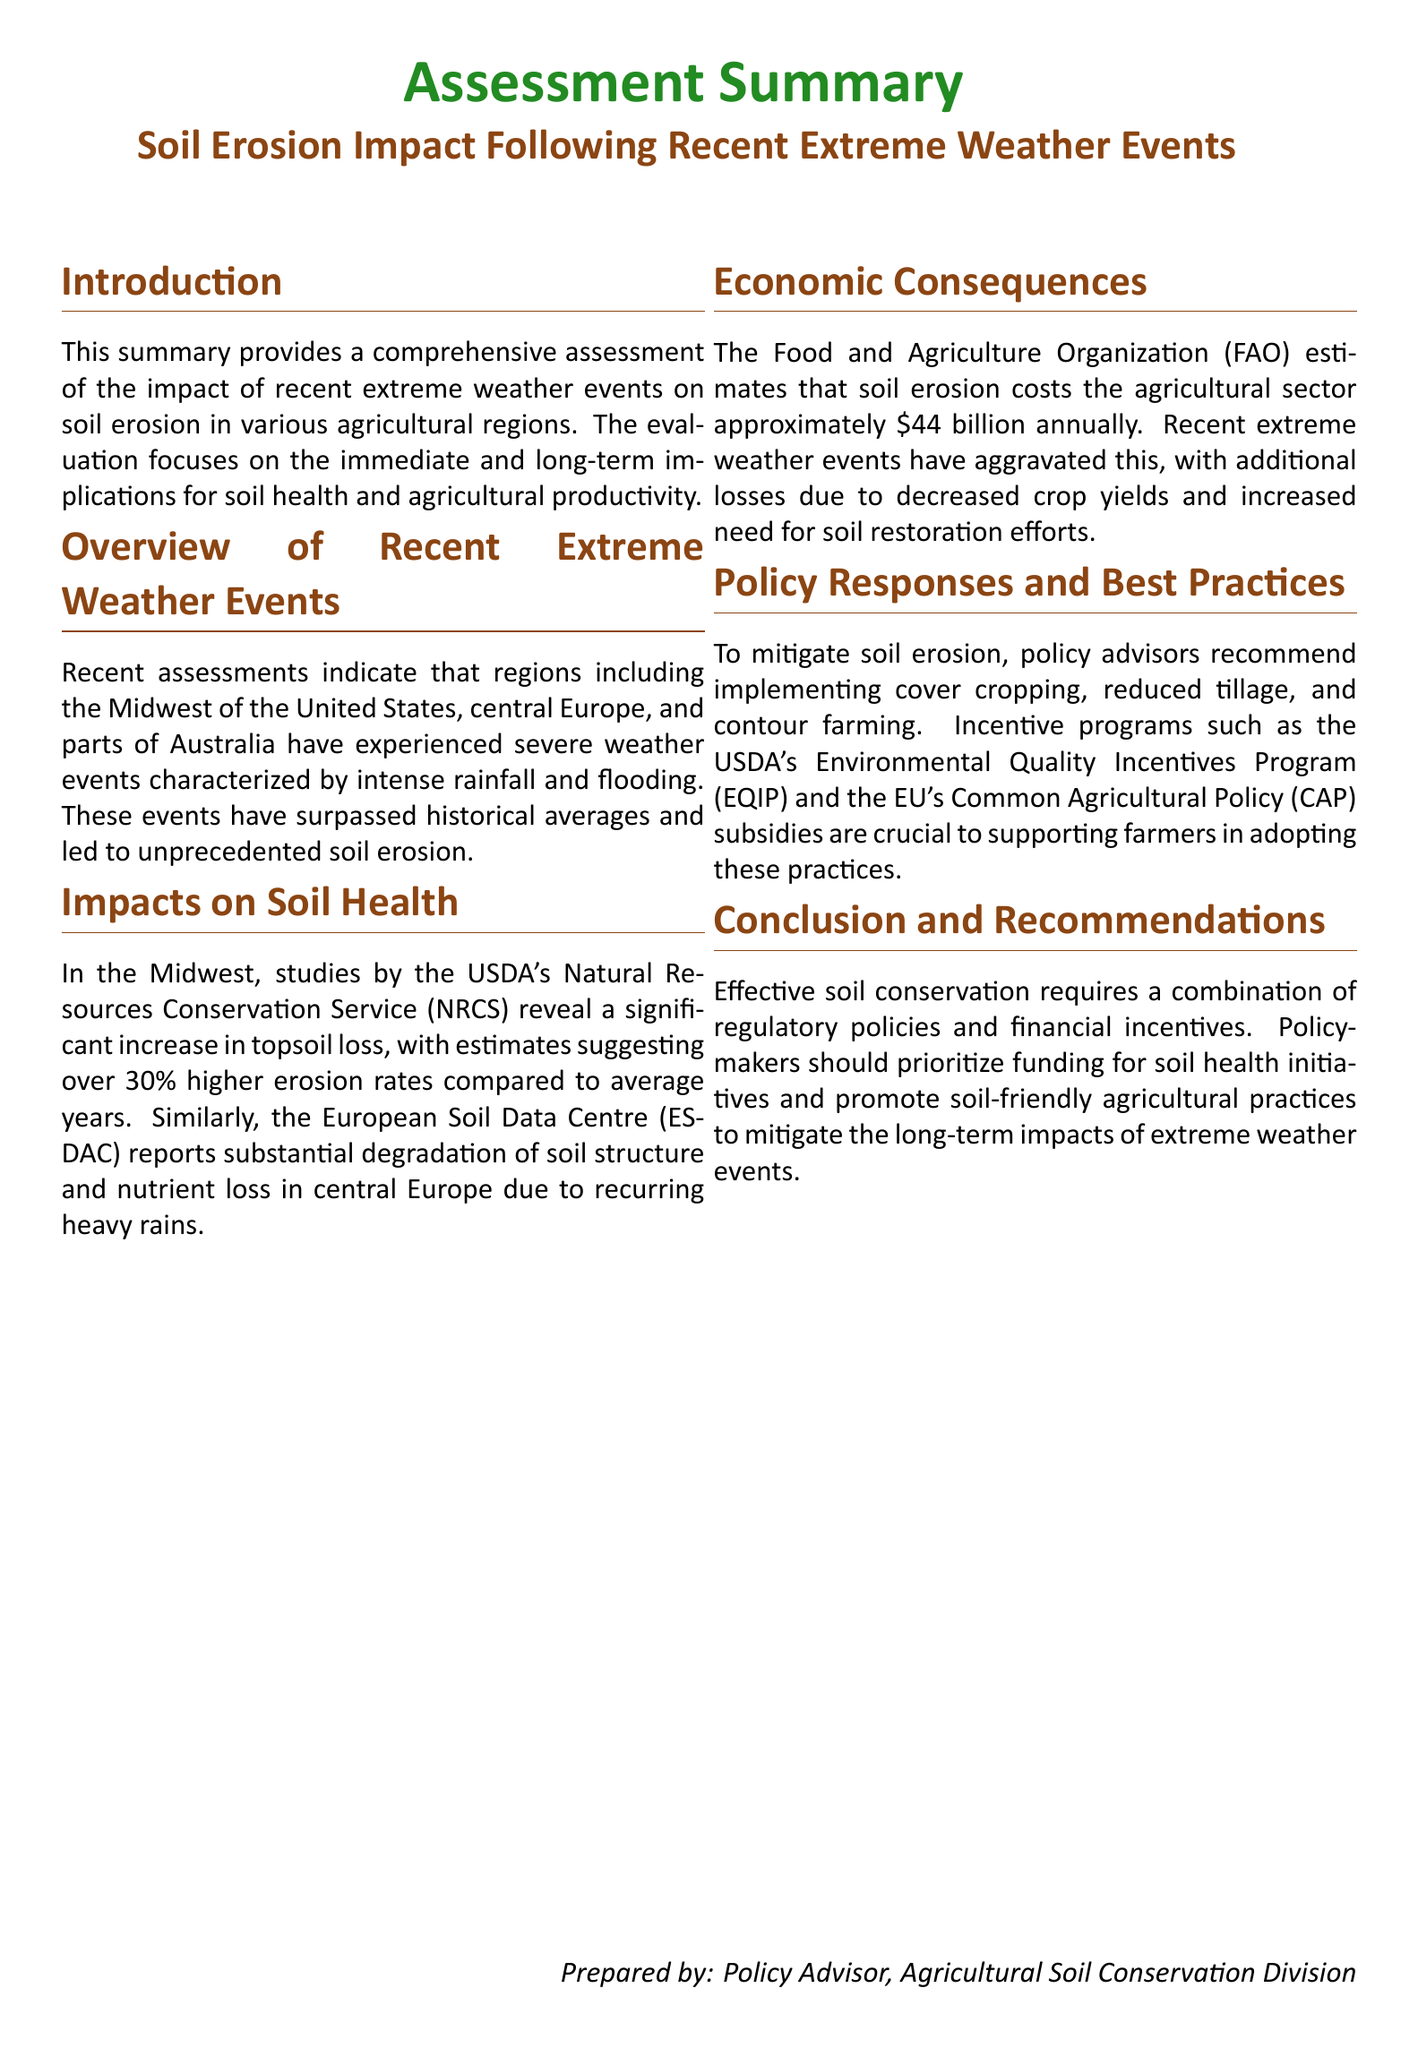What is the title of the document? The title of the document is the main heading provided at the top of the summary.
Answer: Soil Erosion Impact Following Recent Extreme Weather Events What is the estimated increase in topsoil loss in the Midwest? The document provides specific percentage estimates of topsoil loss in the Midwest affected by recent weather events.
Answer: Over 30% What organization provides the soil erosion cost estimate? The document mentions a specific organization that calculates the economic impact of soil erosion on agriculture.
Answer: Food and Agriculture Organization (FAO) What agricultural practice is recommended to mitigate soil erosion? The document lists practices that are advised to prevent soil erosion in agricultural sectors.
Answer: Cover cropping What is the annual cost of soil erosion to the agricultural sector? The document specifies the financial impact of soil erosion on the agricultural sector.
Answer: Approximately $44 billion What type of policy program is mentioned to support farmers? The document discusses specific incentive programs that help farmers implement soil conservation practices.
Answer: Environmental Quality Incentives Program (EQIP) Which regions are highlighted as experiencing extreme weather events? The document provides examples of geographical areas that have faced severe weather and its consequences.
Answer: Midwest of the United States, central Europe, and parts of Australia What does the document recommend as a combination for effective soil conservation? The document suggests a holistic approach to soil conservation, combining different strategies.
Answer: Regulatory policies and financial incentives 